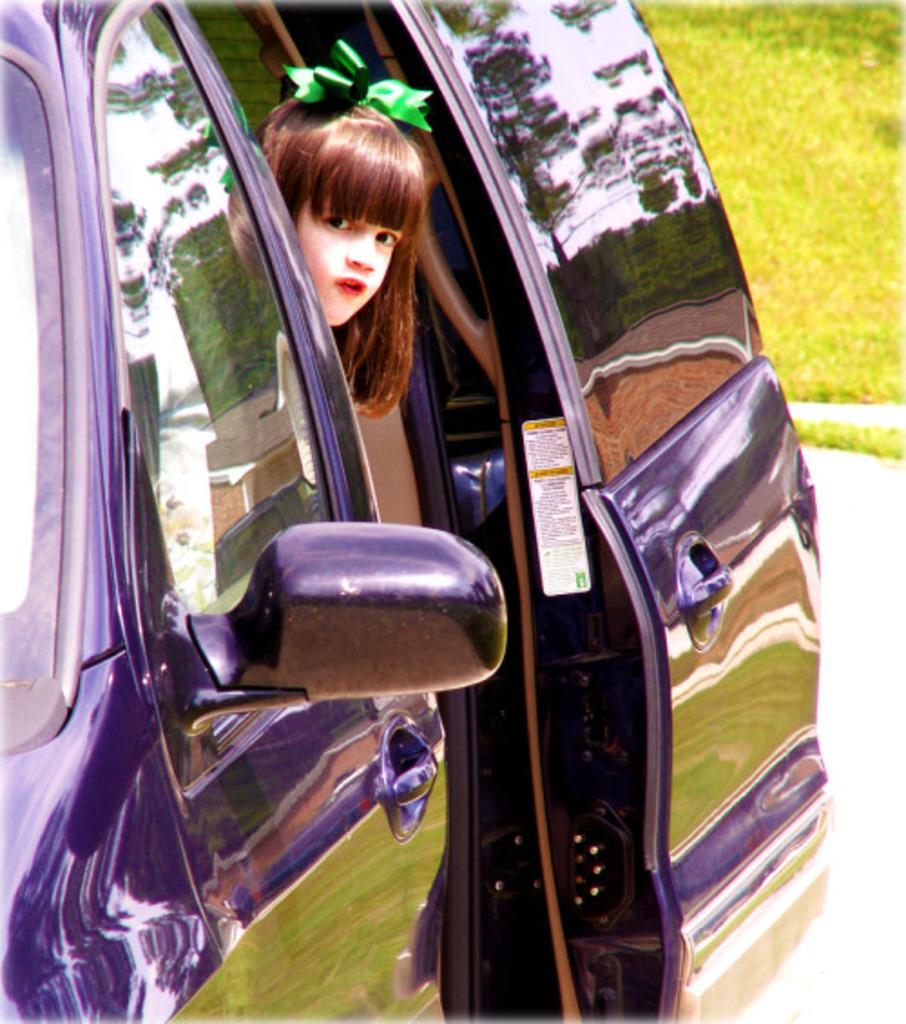How would you summarize this image in a sentence or two? In this image i can see a kid who is sitting in a blue color car. 